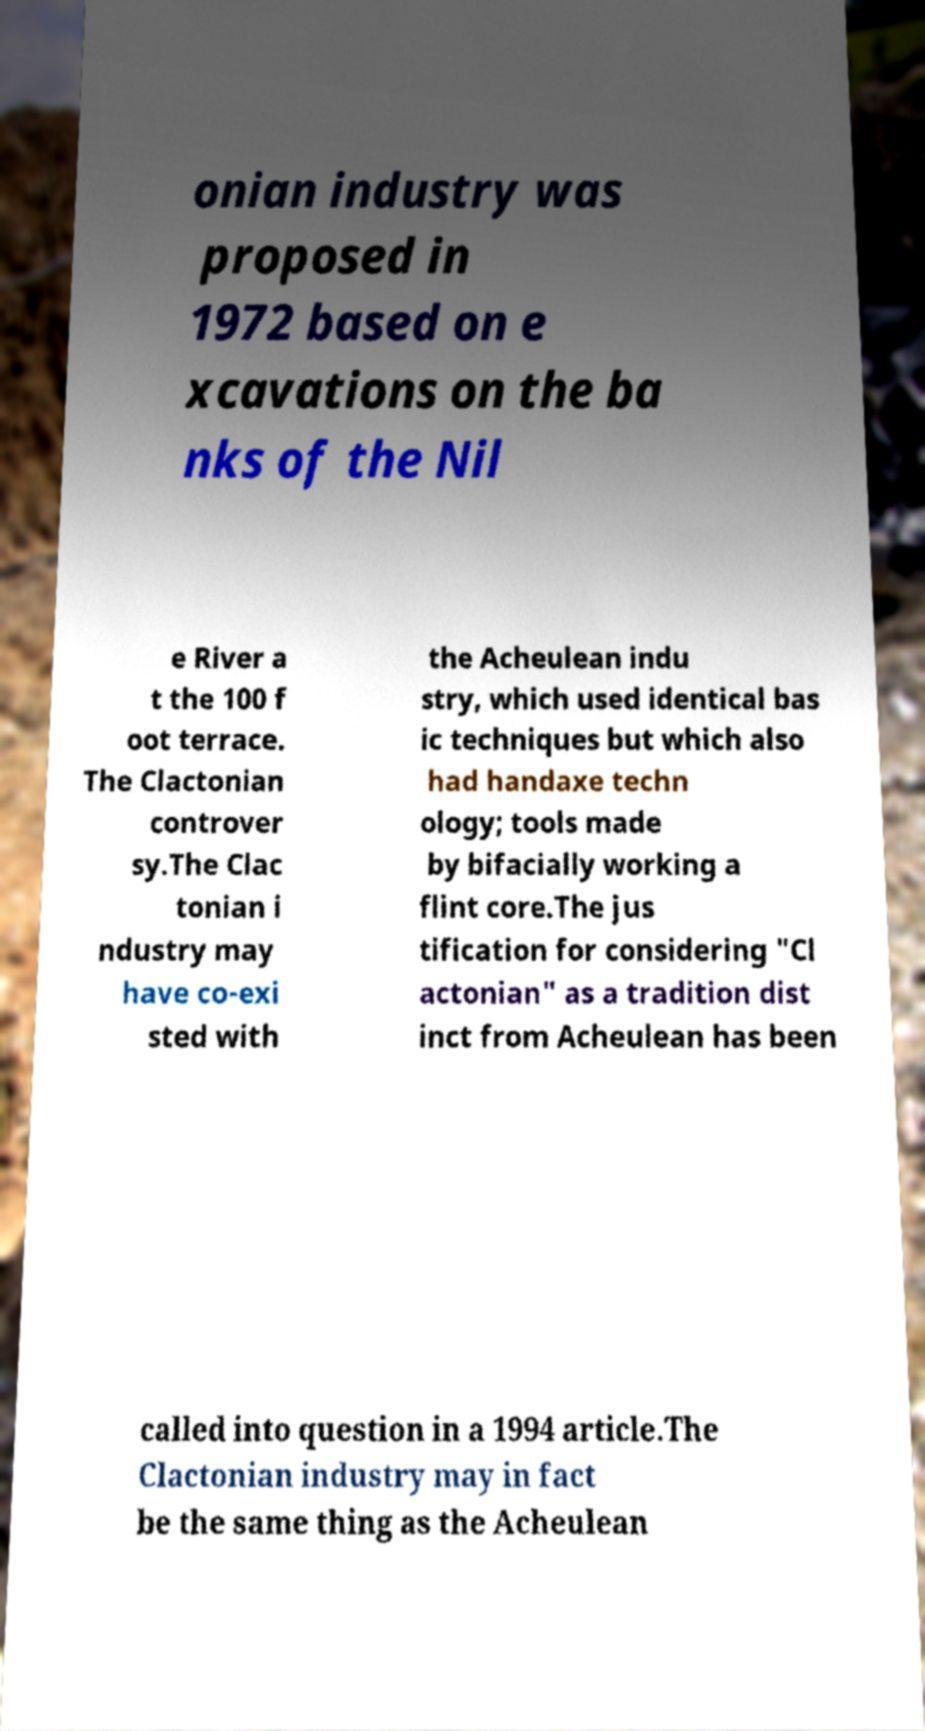Please read and relay the text visible in this image. What does it say? onian industry was proposed in 1972 based on e xcavations on the ba nks of the Nil e River a t the 100 f oot terrace. The Clactonian controver sy.The Clac tonian i ndustry may have co-exi sted with the Acheulean indu stry, which used identical bas ic techniques but which also had handaxe techn ology; tools made by bifacially working a flint core.The jus tification for considering "Cl actonian" as a tradition dist inct from Acheulean has been called into question in a 1994 article.The Clactonian industry may in fact be the same thing as the Acheulean 